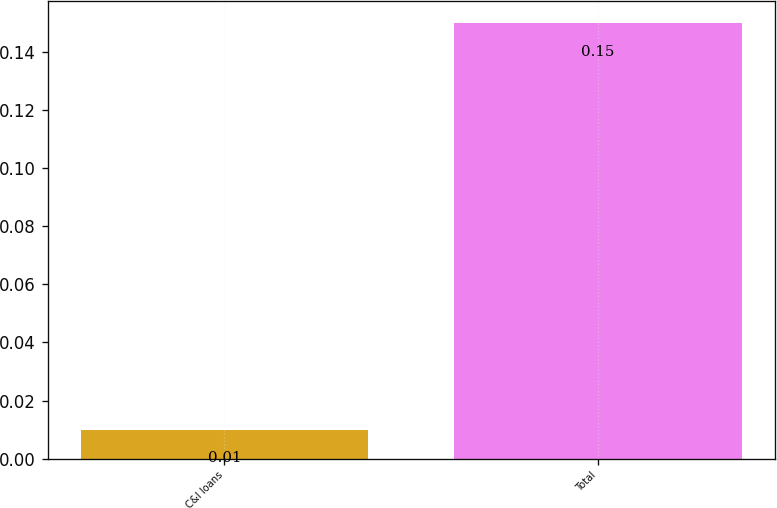Convert chart to OTSL. <chart><loc_0><loc_0><loc_500><loc_500><bar_chart><fcel>C&I loans<fcel>Total<nl><fcel>0.01<fcel>0.15<nl></chart> 